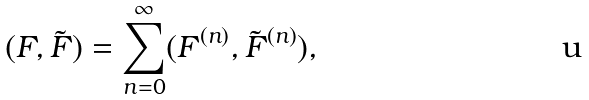<formula> <loc_0><loc_0><loc_500><loc_500>( F , \tilde { F } ) = \sum _ { n = 0 } ^ { \infty } ( F ^ { ( n ) } , \tilde { F } ^ { ( n ) } ) ,</formula> 